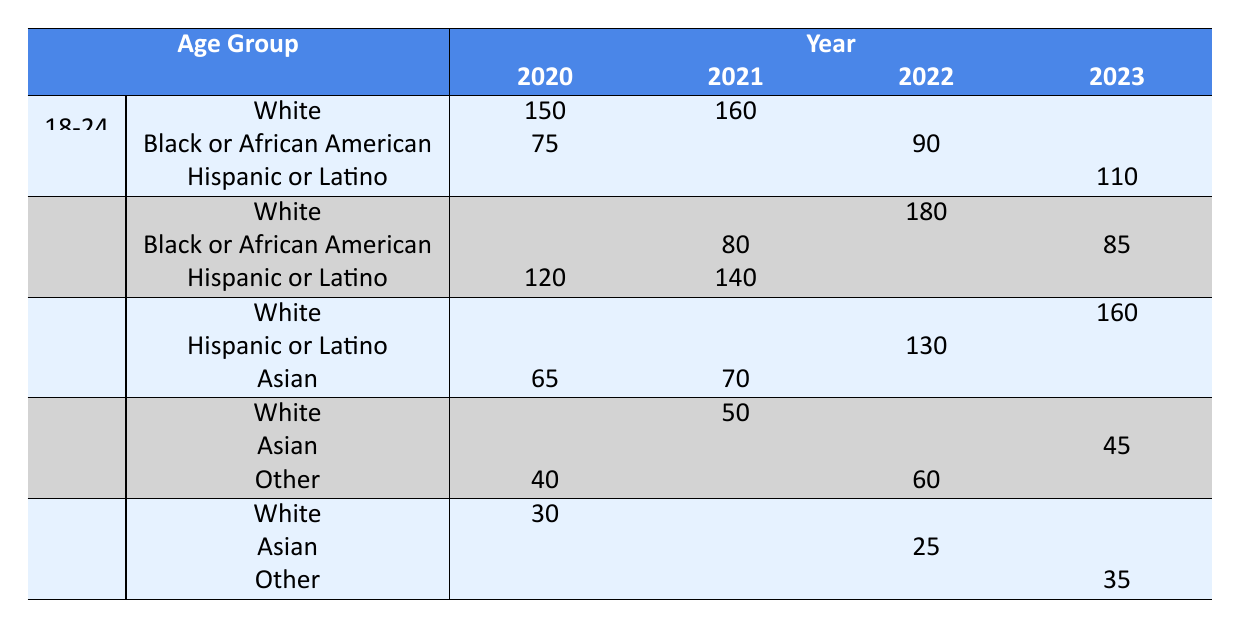What was the utilization count for Hispanic or Latino women aged 25-34 in 2021? In 2021, the table shows a utilization count of 140 for Hispanic or Latino women in the age group 25-34.
Answer: 140 How many women aged 18-24 utilized the shelter in 2020? The table indicates that 150 White and 75 Black or African American women aged 18-24 utilized the shelter in 2020. Adding these gives 150 + 75 = 225.
Answer: 225 Did the utilization count for White women in the age group 45-54 increase or decrease from 2020 to 2021? In 2020, the utilization count for White women aged 45-54 was 0. In 2021, it was 50. This is an increase.
Answer: Increase What is the total utilization count for Asian women across all age groups in the year 2022? For Asian women in 2022, there were 0 counts for 18-24, 0 for 25-34, 0 for 35-44, 0 for 45-54, and 25 for 55+. Therefore, 0 + 0 + 0 + 0 + 25 = 25.
Answer: 25 Which age group had the highest total utilization count in 2023, and what was that count? In 2023, the age group 35-44 had a count of 160 for White women, which is the highest sum across the groups when comparing with other age groups.
Answer: 160 Is there a year where the utilization count for both White and Black or African American women aged 18-24 was recorded? Yes, in both 2020 and 2021, utilization counts for White (150 in 2020, 160 in 2021) and Black or African American (75 in 2020, none in 2021) were recorded, but only 2020 had counts for both.
Answer: Yes What is the average utilization count for Native American women over the years? The table shows that there are no recorded utilizations for Native American women across all years (2020-2023). Thus, the total is 0, and the average is 0.
Answer: 0 How does the 2022 utilization count for Hispanic or Latino women aged 35-44 compare to the 2023 count for the same group? The 2022 count for Hispanic or Latino aged 35-44 is 130, while in 2023, the count is 0. Thus, there’s a decrease of 130.
Answer: Decrease What was the total number of women utilizing the shelter aged 25-34 across all ethnicities in 2020? The utilization counts for 25-34 in 2020 were 0 for White, 0 for Black or African American, 120 for Hispanic or Latino, 0 for Asian, resulting in a total of 120.
Answer: 120 Which ethnicity had the largest number of women utilizing the shelter in the age group 55+ in 2022? According to the table, there were 0 counts for White, 0 for Asian, and 25 for Other. Thus, "Other" had the largest number with 25 women.
Answer: Other 